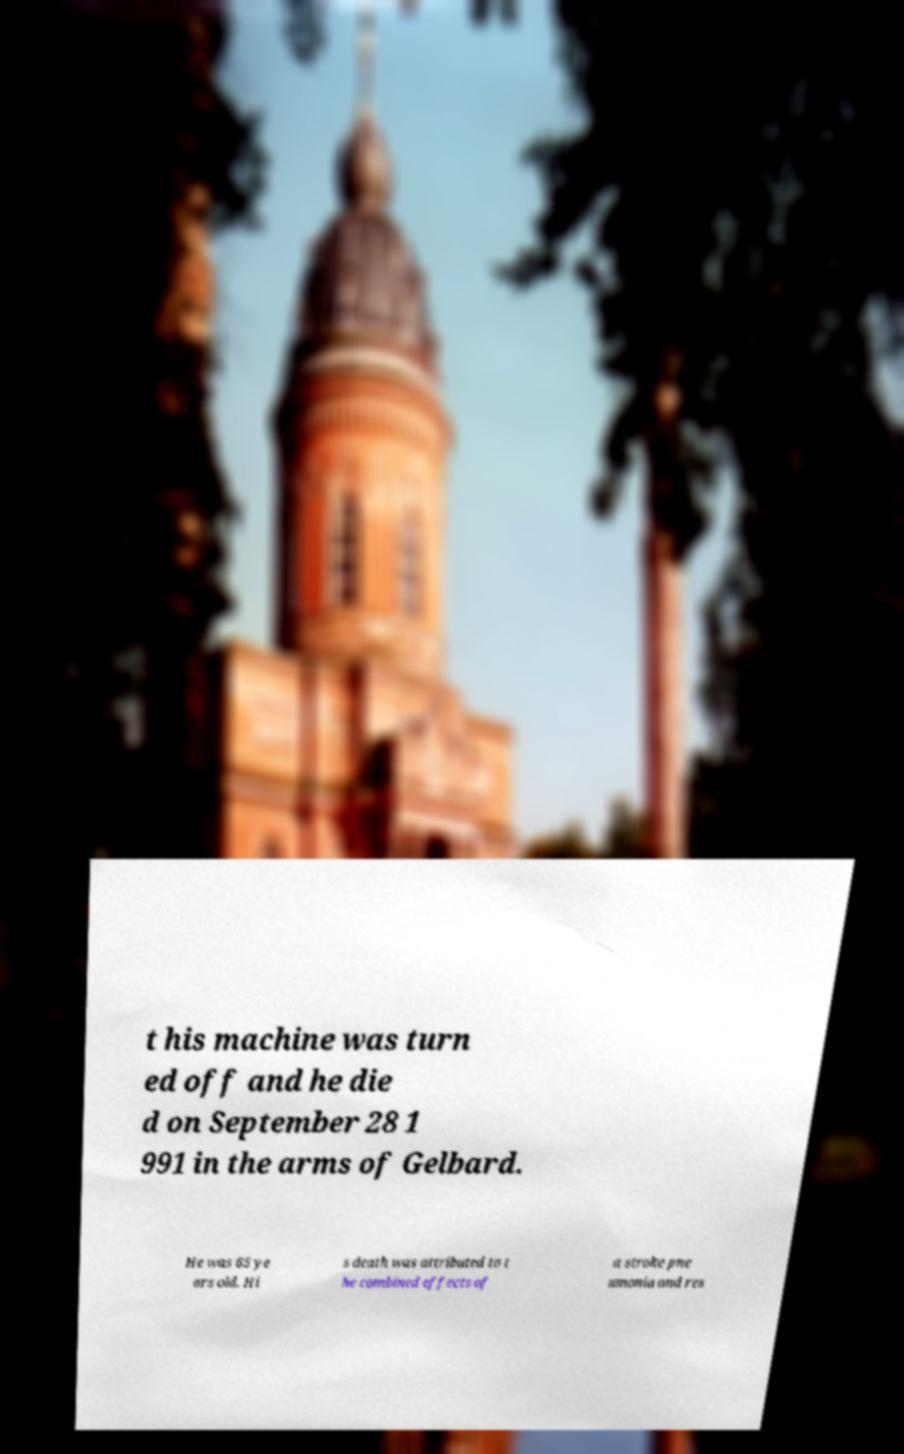There's text embedded in this image that I need extracted. Can you transcribe it verbatim? t his machine was turn ed off and he die d on September 28 1 991 in the arms of Gelbard. He was 65 ye ars old. Hi s death was attributed to t he combined effects of a stroke pne umonia and res 